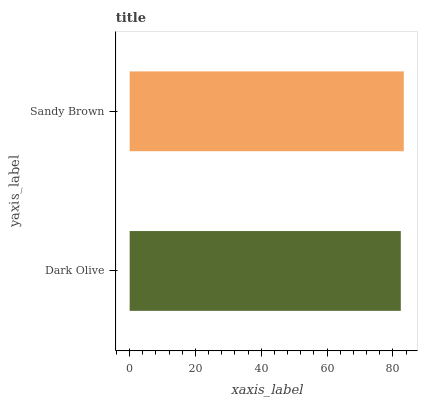Is Dark Olive the minimum?
Answer yes or no. Yes. Is Sandy Brown the maximum?
Answer yes or no. Yes. Is Sandy Brown the minimum?
Answer yes or no. No. Is Sandy Brown greater than Dark Olive?
Answer yes or no. Yes. Is Dark Olive less than Sandy Brown?
Answer yes or no. Yes. Is Dark Olive greater than Sandy Brown?
Answer yes or no. No. Is Sandy Brown less than Dark Olive?
Answer yes or no. No. Is Sandy Brown the high median?
Answer yes or no. Yes. Is Dark Olive the low median?
Answer yes or no. Yes. Is Dark Olive the high median?
Answer yes or no. No. Is Sandy Brown the low median?
Answer yes or no. No. 